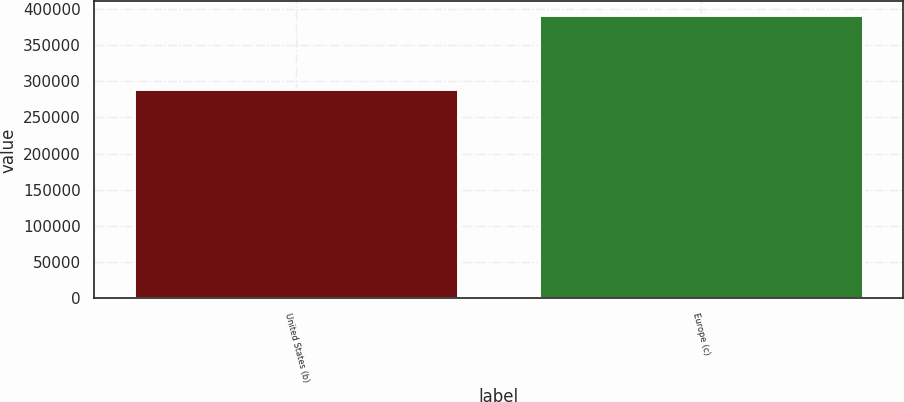Convert chart to OTSL. <chart><loc_0><loc_0><loc_500><loc_500><bar_chart><fcel>United States (b)<fcel>Europe (c)<nl><fcel>288802<fcel>390619<nl></chart> 